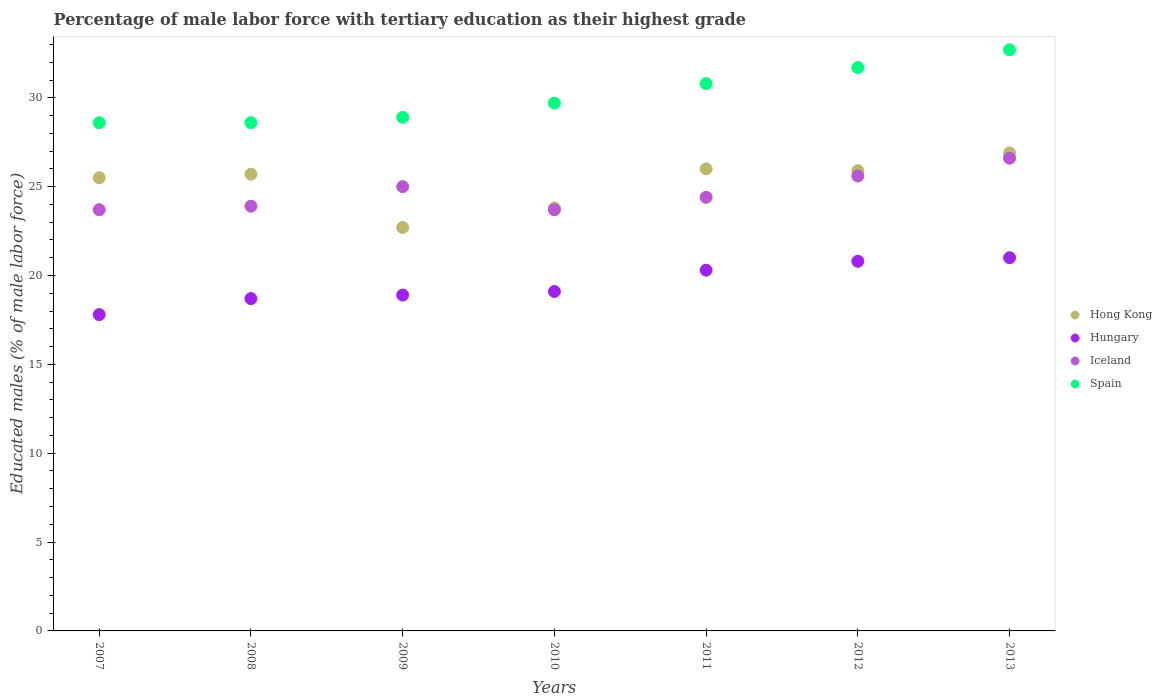Is the number of dotlines equal to the number of legend labels?
Offer a very short reply. Yes. What is the percentage of male labor force with tertiary education in Hong Kong in 2007?
Provide a short and direct response. 25.5. Across all years, what is the maximum percentage of male labor force with tertiary education in Spain?
Keep it short and to the point. 32.7. Across all years, what is the minimum percentage of male labor force with tertiary education in Hong Kong?
Provide a short and direct response. 22.7. In which year was the percentage of male labor force with tertiary education in Hong Kong maximum?
Make the answer very short. 2013. What is the total percentage of male labor force with tertiary education in Hong Kong in the graph?
Your answer should be very brief. 176.5. What is the difference between the percentage of male labor force with tertiary education in Hungary in 2013 and the percentage of male labor force with tertiary education in Spain in 2007?
Ensure brevity in your answer.  -7.6. What is the average percentage of male labor force with tertiary education in Spain per year?
Ensure brevity in your answer.  30.14. In the year 2009, what is the difference between the percentage of male labor force with tertiary education in Hong Kong and percentage of male labor force with tertiary education in Spain?
Keep it short and to the point. -6.2. What is the ratio of the percentage of male labor force with tertiary education in Hong Kong in 2007 to that in 2009?
Keep it short and to the point. 1.12. Is the percentage of male labor force with tertiary education in Hungary in 2007 less than that in 2012?
Keep it short and to the point. Yes. Is the difference between the percentage of male labor force with tertiary education in Hong Kong in 2007 and 2013 greater than the difference between the percentage of male labor force with tertiary education in Spain in 2007 and 2013?
Your response must be concise. Yes. What is the difference between the highest and the second highest percentage of male labor force with tertiary education in Iceland?
Give a very brief answer. 1. What is the difference between the highest and the lowest percentage of male labor force with tertiary education in Spain?
Your answer should be compact. 4.1. Is the sum of the percentage of male labor force with tertiary education in Iceland in 2008 and 2013 greater than the maximum percentage of male labor force with tertiary education in Spain across all years?
Keep it short and to the point. Yes. Is it the case that in every year, the sum of the percentage of male labor force with tertiary education in Iceland and percentage of male labor force with tertiary education in Hungary  is greater than the percentage of male labor force with tertiary education in Spain?
Your answer should be compact. Yes. Does the percentage of male labor force with tertiary education in Iceland monotonically increase over the years?
Offer a terse response. No. Is the percentage of male labor force with tertiary education in Spain strictly greater than the percentage of male labor force with tertiary education in Hong Kong over the years?
Your response must be concise. Yes. Is the percentage of male labor force with tertiary education in Hungary strictly less than the percentage of male labor force with tertiary education in Iceland over the years?
Provide a succinct answer. Yes. How many dotlines are there?
Your answer should be compact. 4. What is the difference between two consecutive major ticks on the Y-axis?
Make the answer very short. 5. Does the graph contain any zero values?
Make the answer very short. No. What is the title of the graph?
Provide a short and direct response. Percentage of male labor force with tertiary education as their highest grade. What is the label or title of the X-axis?
Provide a succinct answer. Years. What is the label or title of the Y-axis?
Provide a succinct answer. Educated males (% of male labor force). What is the Educated males (% of male labor force) of Hungary in 2007?
Your answer should be compact. 17.8. What is the Educated males (% of male labor force) in Iceland in 2007?
Provide a succinct answer. 23.7. What is the Educated males (% of male labor force) of Spain in 2007?
Offer a very short reply. 28.6. What is the Educated males (% of male labor force) of Hong Kong in 2008?
Your answer should be compact. 25.7. What is the Educated males (% of male labor force) in Hungary in 2008?
Provide a succinct answer. 18.7. What is the Educated males (% of male labor force) in Iceland in 2008?
Offer a terse response. 23.9. What is the Educated males (% of male labor force) of Spain in 2008?
Your response must be concise. 28.6. What is the Educated males (% of male labor force) of Hong Kong in 2009?
Keep it short and to the point. 22.7. What is the Educated males (% of male labor force) in Hungary in 2009?
Offer a terse response. 18.9. What is the Educated males (% of male labor force) in Spain in 2009?
Give a very brief answer. 28.9. What is the Educated males (% of male labor force) in Hong Kong in 2010?
Make the answer very short. 23.8. What is the Educated males (% of male labor force) in Hungary in 2010?
Your answer should be compact. 19.1. What is the Educated males (% of male labor force) in Iceland in 2010?
Keep it short and to the point. 23.7. What is the Educated males (% of male labor force) in Spain in 2010?
Give a very brief answer. 29.7. What is the Educated males (% of male labor force) in Hong Kong in 2011?
Your response must be concise. 26. What is the Educated males (% of male labor force) of Hungary in 2011?
Ensure brevity in your answer.  20.3. What is the Educated males (% of male labor force) of Iceland in 2011?
Offer a very short reply. 24.4. What is the Educated males (% of male labor force) in Spain in 2011?
Offer a terse response. 30.8. What is the Educated males (% of male labor force) of Hong Kong in 2012?
Your response must be concise. 25.9. What is the Educated males (% of male labor force) in Hungary in 2012?
Your response must be concise. 20.8. What is the Educated males (% of male labor force) of Iceland in 2012?
Offer a terse response. 25.6. What is the Educated males (% of male labor force) of Spain in 2012?
Make the answer very short. 31.7. What is the Educated males (% of male labor force) of Hong Kong in 2013?
Your response must be concise. 26.9. What is the Educated males (% of male labor force) of Hungary in 2013?
Ensure brevity in your answer.  21. What is the Educated males (% of male labor force) in Iceland in 2013?
Give a very brief answer. 26.6. What is the Educated males (% of male labor force) of Spain in 2013?
Offer a terse response. 32.7. Across all years, what is the maximum Educated males (% of male labor force) of Hong Kong?
Give a very brief answer. 26.9. Across all years, what is the maximum Educated males (% of male labor force) of Hungary?
Your response must be concise. 21. Across all years, what is the maximum Educated males (% of male labor force) in Iceland?
Your answer should be compact. 26.6. Across all years, what is the maximum Educated males (% of male labor force) in Spain?
Give a very brief answer. 32.7. Across all years, what is the minimum Educated males (% of male labor force) in Hong Kong?
Keep it short and to the point. 22.7. Across all years, what is the minimum Educated males (% of male labor force) in Hungary?
Keep it short and to the point. 17.8. Across all years, what is the minimum Educated males (% of male labor force) of Iceland?
Provide a succinct answer. 23.7. Across all years, what is the minimum Educated males (% of male labor force) in Spain?
Give a very brief answer. 28.6. What is the total Educated males (% of male labor force) in Hong Kong in the graph?
Your response must be concise. 176.5. What is the total Educated males (% of male labor force) of Hungary in the graph?
Your answer should be compact. 136.6. What is the total Educated males (% of male labor force) in Iceland in the graph?
Your answer should be compact. 172.9. What is the total Educated males (% of male labor force) in Spain in the graph?
Make the answer very short. 211. What is the difference between the Educated males (% of male labor force) of Hong Kong in 2007 and that in 2008?
Make the answer very short. -0.2. What is the difference between the Educated males (% of male labor force) of Iceland in 2007 and that in 2008?
Give a very brief answer. -0.2. What is the difference between the Educated males (% of male labor force) of Hong Kong in 2007 and that in 2009?
Give a very brief answer. 2.8. What is the difference between the Educated males (% of male labor force) in Hungary in 2007 and that in 2009?
Offer a very short reply. -1.1. What is the difference between the Educated males (% of male labor force) of Iceland in 2007 and that in 2009?
Your answer should be very brief. -1.3. What is the difference between the Educated males (% of male labor force) of Spain in 2007 and that in 2009?
Your response must be concise. -0.3. What is the difference between the Educated males (% of male labor force) of Spain in 2007 and that in 2010?
Your answer should be compact. -1.1. What is the difference between the Educated males (% of male labor force) of Hong Kong in 2007 and that in 2011?
Give a very brief answer. -0.5. What is the difference between the Educated males (% of male labor force) of Hungary in 2007 and that in 2011?
Your response must be concise. -2.5. What is the difference between the Educated males (% of male labor force) of Iceland in 2007 and that in 2011?
Keep it short and to the point. -0.7. What is the difference between the Educated males (% of male labor force) of Hong Kong in 2007 and that in 2012?
Offer a very short reply. -0.4. What is the difference between the Educated males (% of male labor force) in Hungary in 2007 and that in 2012?
Offer a terse response. -3. What is the difference between the Educated males (% of male labor force) of Iceland in 2007 and that in 2012?
Make the answer very short. -1.9. What is the difference between the Educated males (% of male labor force) of Iceland in 2007 and that in 2013?
Ensure brevity in your answer.  -2.9. What is the difference between the Educated males (% of male labor force) of Hungary in 2008 and that in 2009?
Give a very brief answer. -0.2. What is the difference between the Educated males (% of male labor force) in Hong Kong in 2008 and that in 2010?
Your answer should be very brief. 1.9. What is the difference between the Educated males (% of male labor force) of Hungary in 2008 and that in 2010?
Your response must be concise. -0.4. What is the difference between the Educated males (% of male labor force) of Hungary in 2008 and that in 2011?
Make the answer very short. -1.6. What is the difference between the Educated males (% of male labor force) in Spain in 2008 and that in 2011?
Offer a terse response. -2.2. What is the difference between the Educated males (% of male labor force) of Iceland in 2008 and that in 2012?
Your answer should be very brief. -1.7. What is the difference between the Educated males (% of male labor force) in Hong Kong in 2008 and that in 2013?
Keep it short and to the point. -1.2. What is the difference between the Educated males (% of male labor force) in Hungary in 2008 and that in 2013?
Your response must be concise. -2.3. What is the difference between the Educated males (% of male labor force) of Spain in 2008 and that in 2013?
Offer a terse response. -4.1. What is the difference between the Educated males (% of male labor force) in Hong Kong in 2009 and that in 2010?
Provide a short and direct response. -1.1. What is the difference between the Educated males (% of male labor force) in Spain in 2009 and that in 2010?
Give a very brief answer. -0.8. What is the difference between the Educated males (% of male labor force) of Hong Kong in 2009 and that in 2011?
Give a very brief answer. -3.3. What is the difference between the Educated males (% of male labor force) in Iceland in 2009 and that in 2011?
Provide a succinct answer. 0.6. What is the difference between the Educated males (% of male labor force) in Hong Kong in 2009 and that in 2012?
Give a very brief answer. -3.2. What is the difference between the Educated males (% of male labor force) of Iceland in 2009 and that in 2012?
Offer a very short reply. -0.6. What is the difference between the Educated males (% of male labor force) in Spain in 2009 and that in 2012?
Ensure brevity in your answer.  -2.8. What is the difference between the Educated males (% of male labor force) of Iceland in 2009 and that in 2013?
Offer a very short reply. -1.6. What is the difference between the Educated males (% of male labor force) in Spain in 2009 and that in 2013?
Make the answer very short. -3.8. What is the difference between the Educated males (% of male labor force) in Hong Kong in 2010 and that in 2011?
Provide a succinct answer. -2.2. What is the difference between the Educated males (% of male labor force) of Hungary in 2010 and that in 2011?
Give a very brief answer. -1.2. What is the difference between the Educated males (% of male labor force) in Iceland in 2010 and that in 2011?
Your answer should be very brief. -0.7. What is the difference between the Educated males (% of male labor force) in Hong Kong in 2010 and that in 2012?
Provide a succinct answer. -2.1. What is the difference between the Educated males (% of male labor force) in Iceland in 2010 and that in 2012?
Your answer should be very brief. -1.9. What is the difference between the Educated males (% of male labor force) in Hong Kong in 2010 and that in 2013?
Provide a succinct answer. -3.1. What is the difference between the Educated males (% of male labor force) of Iceland in 2010 and that in 2013?
Give a very brief answer. -2.9. What is the difference between the Educated males (% of male labor force) of Spain in 2010 and that in 2013?
Your response must be concise. -3. What is the difference between the Educated males (% of male labor force) in Hungary in 2011 and that in 2012?
Provide a succinct answer. -0.5. What is the difference between the Educated males (% of male labor force) in Hong Kong in 2011 and that in 2013?
Offer a very short reply. -0.9. What is the difference between the Educated males (% of male labor force) in Hungary in 2012 and that in 2013?
Your answer should be compact. -0.2. What is the difference between the Educated males (% of male labor force) in Spain in 2012 and that in 2013?
Offer a terse response. -1. What is the difference between the Educated males (% of male labor force) of Hong Kong in 2007 and the Educated males (% of male labor force) of Hungary in 2008?
Your response must be concise. 6.8. What is the difference between the Educated males (% of male labor force) in Hungary in 2007 and the Educated males (% of male labor force) in Spain in 2008?
Ensure brevity in your answer.  -10.8. What is the difference between the Educated males (% of male labor force) of Hong Kong in 2007 and the Educated males (% of male labor force) of Hungary in 2009?
Your answer should be very brief. 6.6. What is the difference between the Educated males (% of male labor force) of Hungary in 2007 and the Educated males (% of male labor force) of Spain in 2009?
Ensure brevity in your answer.  -11.1. What is the difference between the Educated males (% of male labor force) of Hungary in 2007 and the Educated males (% of male labor force) of Iceland in 2010?
Your answer should be compact. -5.9. What is the difference between the Educated males (% of male labor force) in Hungary in 2007 and the Educated males (% of male labor force) in Spain in 2010?
Provide a succinct answer. -11.9. What is the difference between the Educated males (% of male labor force) of Iceland in 2007 and the Educated males (% of male labor force) of Spain in 2010?
Your answer should be compact. -6. What is the difference between the Educated males (% of male labor force) of Hong Kong in 2007 and the Educated males (% of male labor force) of Iceland in 2011?
Keep it short and to the point. 1.1. What is the difference between the Educated males (% of male labor force) of Hungary in 2007 and the Educated males (% of male labor force) of Iceland in 2011?
Give a very brief answer. -6.6. What is the difference between the Educated males (% of male labor force) of Iceland in 2007 and the Educated males (% of male labor force) of Spain in 2011?
Offer a terse response. -7.1. What is the difference between the Educated males (% of male labor force) of Hong Kong in 2007 and the Educated males (% of male labor force) of Iceland in 2012?
Make the answer very short. -0.1. What is the difference between the Educated males (% of male labor force) in Hong Kong in 2007 and the Educated males (% of male labor force) in Spain in 2012?
Your answer should be very brief. -6.2. What is the difference between the Educated males (% of male labor force) in Hungary in 2007 and the Educated males (% of male labor force) in Iceland in 2012?
Make the answer very short. -7.8. What is the difference between the Educated males (% of male labor force) in Hungary in 2007 and the Educated males (% of male labor force) in Spain in 2012?
Your response must be concise. -13.9. What is the difference between the Educated males (% of male labor force) of Hong Kong in 2007 and the Educated males (% of male labor force) of Iceland in 2013?
Provide a succinct answer. -1.1. What is the difference between the Educated males (% of male labor force) in Hong Kong in 2007 and the Educated males (% of male labor force) in Spain in 2013?
Keep it short and to the point. -7.2. What is the difference between the Educated males (% of male labor force) of Hungary in 2007 and the Educated males (% of male labor force) of Spain in 2013?
Provide a short and direct response. -14.9. What is the difference between the Educated males (% of male labor force) of Iceland in 2007 and the Educated males (% of male labor force) of Spain in 2013?
Your answer should be compact. -9. What is the difference between the Educated males (% of male labor force) of Hong Kong in 2008 and the Educated males (% of male labor force) of Hungary in 2009?
Make the answer very short. 6.8. What is the difference between the Educated males (% of male labor force) in Hungary in 2008 and the Educated males (% of male labor force) in Iceland in 2009?
Provide a short and direct response. -6.3. What is the difference between the Educated males (% of male labor force) in Iceland in 2008 and the Educated males (% of male labor force) in Spain in 2009?
Provide a succinct answer. -5. What is the difference between the Educated males (% of male labor force) in Hong Kong in 2008 and the Educated males (% of male labor force) in Iceland in 2010?
Give a very brief answer. 2. What is the difference between the Educated males (% of male labor force) in Hong Kong in 2008 and the Educated males (% of male labor force) in Spain in 2010?
Provide a short and direct response. -4. What is the difference between the Educated males (% of male labor force) in Hungary in 2008 and the Educated males (% of male labor force) in Spain in 2010?
Your response must be concise. -11. What is the difference between the Educated males (% of male labor force) of Hong Kong in 2008 and the Educated males (% of male labor force) of Hungary in 2012?
Your answer should be compact. 4.9. What is the difference between the Educated males (% of male labor force) in Hong Kong in 2008 and the Educated males (% of male labor force) in Hungary in 2013?
Provide a succinct answer. 4.7. What is the difference between the Educated males (% of male labor force) in Hungary in 2008 and the Educated males (% of male labor force) in Iceland in 2013?
Make the answer very short. -7.9. What is the difference between the Educated males (% of male labor force) of Hungary in 2008 and the Educated males (% of male labor force) of Spain in 2013?
Offer a terse response. -14. What is the difference between the Educated males (% of male labor force) of Hong Kong in 2009 and the Educated males (% of male labor force) of Hungary in 2010?
Your answer should be very brief. 3.6. What is the difference between the Educated males (% of male labor force) of Hong Kong in 2009 and the Educated males (% of male labor force) of Spain in 2010?
Make the answer very short. -7. What is the difference between the Educated males (% of male labor force) in Hungary in 2009 and the Educated males (% of male labor force) in Iceland in 2010?
Your answer should be compact. -4.8. What is the difference between the Educated males (% of male labor force) in Hungary in 2009 and the Educated males (% of male labor force) in Spain in 2010?
Ensure brevity in your answer.  -10.8. What is the difference between the Educated males (% of male labor force) of Iceland in 2009 and the Educated males (% of male labor force) of Spain in 2010?
Offer a terse response. -4.7. What is the difference between the Educated males (% of male labor force) of Hong Kong in 2009 and the Educated males (% of male labor force) of Spain in 2011?
Provide a succinct answer. -8.1. What is the difference between the Educated males (% of male labor force) in Hungary in 2009 and the Educated males (% of male labor force) in Iceland in 2011?
Offer a terse response. -5.5. What is the difference between the Educated males (% of male labor force) in Hungary in 2009 and the Educated males (% of male labor force) in Spain in 2011?
Ensure brevity in your answer.  -11.9. What is the difference between the Educated males (% of male labor force) in Hong Kong in 2009 and the Educated males (% of male labor force) in Spain in 2012?
Your response must be concise. -9. What is the difference between the Educated males (% of male labor force) in Hungary in 2009 and the Educated males (% of male labor force) in Spain in 2012?
Your response must be concise. -12.8. What is the difference between the Educated males (% of male labor force) in Iceland in 2009 and the Educated males (% of male labor force) in Spain in 2012?
Provide a short and direct response. -6.7. What is the difference between the Educated males (% of male labor force) of Hong Kong in 2009 and the Educated males (% of male labor force) of Iceland in 2013?
Keep it short and to the point. -3.9. What is the difference between the Educated males (% of male labor force) in Hong Kong in 2009 and the Educated males (% of male labor force) in Spain in 2013?
Ensure brevity in your answer.  -10. What is the difference between the Educated males (% of male labor force) in Iceland in 2009 and the Educated males (% of male labor force) in Spain in 2013?
Offer a terse response. -7.7. What is the difference between the Educated males (% of male labor force) in Hungary in 2010 and the Educated males (% of male labor force) in Iceland in 2011?
Your answer should be very brief. -5.3. What is the difference between the Educated males (% of male labor force) in Hungary in 2010 and the Educated males (% of male labor force) in Spain in 2011?
Your response must be concise. -11.7. What is the difference between the Educated males (% of male labor force) in Iceland in 2010 and the Educated males (% of male labor force) in Spain in 2011?
Keep it short and to the point. -7.1. What is the difference between the Educated males (% of male labor force) of Hong Kong in 2010 and the Educated males (% of male labor force) of Spain in 2012?
Give a very brief answer. -7.9. What is the difference between the Educated males (% of male labor force) in Hungary in 2010 and the Educated males (% of male labor force) in Spain in 2012?
Give a very brief answer. -12.6. What is the difference between the Educated males (% of male labor force) in Iceland in 2010 and the Educated males (% of male labor force) in Spain in 2012?
Give a very brief answer. -8. What is the difference between the Educated males (% of male labor force) of Hong Kong in 2010 and the Educated males (% of male labor force) of Hungary in 2013?
Provide a short and direct response. 2.8. What is the difference between the Educated males (% of male labor force) of Iceland in 2010 and the Educated males (% of male labor force) of Spain in 2013?
Keep it short and to the point. -9. What is the difference between the Educated males (% of male labor force) in Hong Kong in 2011 and the Educated males (% of male labor force) in Hungary in 2012?
Provide a short and direct response. 5.2. What is the difference between the Educated males (% of male labor force) of Hong Kong in 2011 and the Educated males (% of male labor force) of Spain in 2012?
Ensure brevity in your answer.  -5.7. What is the difference between the Educated males (% of male labor force) of Hong Kong in 2011 and the Educated males (% of male labor force) of Hungary in 2013?
Make the answer very short. 5. What is the difference between the Educated males (% of male labor force) in Hong Kong in 2011 and the Educated males (% of male labor force) in Iceland in 2013?
Keep it short and to the point. -0.6. What is the difference between the Educated males (% of male labor force) of Hong Kong in 2012 and the Educated males (% of male labor force) of Hungary in 2013?
Give a very brief answer. 4.9. What is the difference between the Educated males (% of male labor force) in Hong Kong in 2012 and the Educated males (% of male labor force) in Iceland in 2013?
Give a very brief answer. -0.7. What is the difference between the Educated males (% of male labor force) in Hungary in 2012 and the Educated males (% of male labor force) in Spain in 2013?
Offer a very short reply. -11.9. What is the difference between the Educated males (% of male labor force) in Iceland in 2012 and the Educated males (% of male labor force) in Spain in 2013?
Keep it short and to the point. -7.1. What is the average Educated males (% of male labor force) of Hong Kong per year?
Provide a succinct answer. 25.21. What is the average Educated males (% of male labor force) of Hungary per year?
Your answer should be compact. 19.51. What is the average Educated males (% of male labor force) in Iceland per year?
Your answer should be very brief. 24.7. What is the average Educated males (% of male labor force) of Spain per year?
Your response must be concise. 30.14. In the year 2007, what is the difference between the Educated males (% of male labor force) in Hong Kong and Educated males (% of male labor force) in Spain?
Give a very brief answer. -3.1. In the year 2007, what is the difference between the Educated males (% of male labor force) in Iceland and Educated males (% of male labor force) in Spain?
Your answer should be compact. -4.9. In the year 2008, what is the difference between the Educated males (% of male labor force) of Hong Kong and Educated males (% of male labor force) of Hungary?
Keep it short and to the point. 7. In the year 2008, what is the difference between the Educated males (% of male labor force) of Hungary and Educated males (% of male labor force) of Spain?
Keep it short and to the point. -9.9. In the year 2009, what is the difference between the Educated males (% of male labor force) in Hong Kong and Educated males (% of male labor force) in Spain?
Provide a succinct answer. -6.2. In the year 2009, what is the difference between the Educated males (% of male labor force) in Hungary and Educated males (% of male labor force) in Iceland?
Offer a terse response. -6.1. In the year 2009, what is the difference between the Educated males (% of male labor force) of Hungary and Educated males (% of male labor force) of Spain?
Offer a very short reply. -10. In the year 2009, what is the difference between the Educated males (% of male labor force) of Iceland and Educated males (% of male labor force) of Spain?
Your answer should be compact. -3.9. In the year 2010, what is the difference between the Educated males (% of male labor force) of Hong Kong and Educated males (% of male labor force) of Iceland?
Provide a short and direct response. 0.1. In the year 2010, what is the difference between the Educated males (% of male labor force) in Hungary and Educated males (% of male labor force) in Spain?
Your response must be concise. -10.6. In the year 2010, what is the difference between the Educated males (% of male labor force) in Iceland and Educated males (% of male labor force) in Spain?
Your answer should be compact. -6. In the year 2011, what is the difference between the Educated males (% of male labor force) of Hong Kong and Educated males (% of male labor force) of Hungary?
Give a very brief answer. 5.7. In the year 2011, what is the difference between the Educated males (% of male labor force) of Hungary and Educated males (% of male labor force) of Spain?
Ensure brevity in your answer.  -10.5. In the year 2012, what is the difference between the Educated males (% of male labor force) in Hong Kong and Educated males (% of male labor force) in Iceland?
Ensure brevity in your answer.  0.3. In the year 2012, what is the difference between the Educated males (% of male labor force) of Hong Kong and Educated males (% of male labor force) of Spain?
Your answer should be very brief. -5.8. In the year 2012, what is the difference between the Educated males (% of male labor force) of Hungary and Educated males (% of male labor force) of Iceland?
Offer a very short reply. -4.8. In the year 2012, what is the difference between the Educated males (% of male labor force) in Hungary and Educated males (% of male labor force) in Spain?
Make the answer very short. -10.9. In the year 2012, what is the difference between the Educated males (% of male labor force) of Iceland and Educated males (% of male labor force) of Spain?
Your answer should be very brief. -6.1. In the year 2013, what is the difference between the Educated males (% of male labor force) in Hong Kong and Educated males (% of male labor force) in Hungary?
Make the answer very short. 5.9. In the year 2013, what is the difference between the Educated males (% of male labor force) of Hungary and Educated males (% of male labor force) of Spain?
Make the answer very short. -11.7. What is the ratio of the Educated males (% of male labor force) in Hungary in 2007 to that in 2008?
Offer a terse response. 0.95. What is the ratio of the Educated males (% of male labor force) in Spain in 2007 to that in 2008?
Your answer should be very brief. 1. What is the ratio of the Educated males (% of male labor force) in Hong Kong in 2007 to that in 2009?
Ensure brevity in your answer.  1.12. What is the ratio of the Educated males (% of male labor force) in Hungary in 2007 to that in 2009?
Ensure brevity in your answer.  0.94. What is the ratio of the Educated males (% of male labor force) of Iceland in 2007 to that in 2009?
Your answer should be compact. 0.95. What is the ratio of the Educated males (% of male labor force) of Spain in 2007 to that in 2009?
Ensure brevity in your answer.  0.99. What is the ratio of the Educated males (% of male labor force) of Hong Kong in 2007 to that in 2010?
Make the answer very short. 1.07. What is the ratio of the Educated males (% of male labor force) in Hungary in 2007 to that in 2010?
Offer a terse response. 0.93. What is the ratio of the Educated males (% of male labor force) in Hong Kong in 2007 to that in 2011?
Offer a very short reply. 0.98. What is the ratio of the Educated males (% of male labor force) in Hungary in 2007 to that in 2011?
Offer a terse response. 0.88. What is the ratio of the Educated males (% of male labor force) in Iceland in 2007 to that in 2011?
Your response must be concise. 0.97. What is the ratio of the Educated males (% of male labor force) of Spain in 2007 to that in 2011?
Ensure brevity in your answer.  0.93. What is the ratio of the Educated males (% of male labor force) of Hong Kong in 2007 to that in 2012?
Make the answer very short. 0.98. What is the ratio of the Educated males (% of male labor force) of Hungary in 2007 to that in 2012?
Your answer should be compact. 0.86. What is the ratio of the Educated males (% of male labor force) of Iceland in 2007 to that in 2012?
Provide a succinct answer. 0.93. What is the ratio of the Educated males (% of male labor force) in Spain in 2007 to that in 2012?
Provide a short and direct response. 0.9. What is the ratio of the Educated males (% of male labor force) of Hong Kong in 2007 to that in 2013?
Your answer should be very brief. 0.95. What is the ratio of the Educated males (% of male labor force) in Hungary in 2007 to that in 2013?
Provide a short and direct response. 0.85. What is the ratio of the Educated males (% of male labor force) of Iceland in 2007 to that in 2013?
Make the answer very short. 0.89. What is the ratio of the Educated males (% of male labor force) of Spain in 2007 to that in 2013?
Offer a terse response. 0.87. What is the ratio of the Educated males (% of male labor force) in Hong Kong in 2008 to that in 2009?
Your answer should be compact. 1.13. What is the ratio of the Educated males (% of male labor force) in Iceland in 2008 to that in 2009?
Your answer should be compact. 0.96. What is the ratio of the Educated males (% of male labor force) in Spain in 2008 to that in 2009?
Give a very brief answer. 0.99. What is the ratio of the Educated males (% of male labor force) in Hong Kong in 2008 to that in 2010?
Your answer should be compact. 1.08. What is the ratio of the Educated males (% of male labor force) in Hungary in 2008 to that in 2010?
Keep it short and to the point. 0.98. What is the ratio of the Educated males (% of male labor force) in Iceland in 2008 to that in 2010?
Ensure brevity in your answer.  1.01. What is the ratio of the Educated males (% of male labor force) in Hungary in 2008 to that in 2011?
Offer a terse response. 0.92. What is the ratio of the Educated males (% of male labor force) of Iceland in 2008 to that in 2011?
Provide a succinct answer. 0.98. What is the ratio of the Educated males (% of male labor force) in Hungary in 2008 to that in 2012?
Your answer should be very brief. 0.9. What is the ratio of the Educated males (% of male labor force) of Iceland in 2008 to that in 2012?
Keep it short and to the point. 0.93. What is the ratio of the Educated males (% of male labor force) of Spain in 2008 to that in 2012?
Your answer should be very brief. 0.9. What is the ratio of the Educated males (% of male labor force) of Hong Kong in 2008 to that in 2013?
Offer a very short reply. 0.96. What is the ratio of the Educated males (% of male labor force) in Hungary in 2008 to that in 2013?
Provide a short and direct response. 0.89. What is the ratio of the Educated males (% of male labor force) of Iceland in 2008 to that in 2013?
Keep it short and to the point. 0.9. What is the ratio of the Educated males (% of male labor force) of Spain in 2008 to that in 2013?
Offer a terse response. 0.87. What is the ratio of the Educated males (% of male labor force) of Hong Kong in 2009 to that in 2010?
Provide a short and direct response. 0.95. What is the ratio of the Educated males (% of male labor force) in Iceland in 2009 to that in 2010?
Offer a terse response. 1.05. What is the ratio of the Educated males (% of male labor force) of Spain in 2009 to that in 2010?
Keep it short and to the point. 0.97. What is the ratio of the Educated males (% of male labor force) in Hong Kong in 2009 to that in 2011?
Make the answer very short. 0.87. What is the ratio of the Educated males (% of male labor force) in Iceland in 2009 to that in 2011?
Your answer should be very brief. 1.02. What is the ratio of the Educated males (% of male labor force) of Spain in 2009 to that in 2011?
Offer a very short reply. 0.94. What is the ratio of the Educated males (% of male labor force) of Hong Kong in 2009 to that in 2012?
Make the answer very short. 0.88. What is the ratio of the Educated males (% of male labor force) of Hungary in 2009 to that in 2012?
Your answer should be compact. 0.91. What is the ratio of the Educated males (% of male labor force) in Iceland in 2009 to that in 2012?
Your answer should be very brief. 0.98. What is the ratio of the Educated males (% of male labor force) in Spain in 2009 to that in 2012?
Your answer should be very brief. 0.91. What is the ratio of the Educated males (% of male labor force) of Hong Kong in 2009 to that in 2013?
Your answer should be very brief. 0.84. What is the ratio of the Educated males (% of male labor force) in Iceland in 2009 to that in 2013?
Provide a short and direct response. 0.94. What is the ratio of the Educated males (% of male labor force) of Spain in 2009 to that in 2013?
Provide a succinct answer. 0.88. What is the ratio of the Educated males (% of male labor force) in Hong Kong in 2010 to that in 2011?
Offer a terse response. 0.92. What is the ratio of the Educated males (% of male labor force) in Hungary in 2010 to that in 2011?
Your answer should be very brief. 0.94. What is the ratio of the Educated males (% of male labor force) in Iceland in 2010 to that in 2011?
Make the answer very short. 0.97. What is the ratio of the Educated males (% of male labor force) of Hong Kong in 2010 to that in 2012?
Provide a short and direct response. 0.92. What is the ratio of the Educated males (% of male labor force) in Hungary in 2010 to that in 2012?
Give a very brief answer. 0.92. What is the ratio of the Educated males (% of male labor force) in Iceland in 2010 to that in 2012?
Your answer should be compact. 0.93. What is the ratio of the Educated males (% of male labor force) in Spain in 2010 to that in 2012?
Your response must be concise. 0.94. What is the ratio of the Educated males (% of male labor force) in Hong Kong in 2010 to that in 2013?
Offer a terse response. 0.88. What is the ratio of the Educated males (% of male labor force) of Hungary in 2010 to that in 2013?
Make the answer very short. 0.91. What is the ratio of the Educated males (% of male labor force) in Iceland in 2010 to that in 2013?
Provide a succinct answer. 0.89. What is the ratio of the Educated males (% of male labor force) of Spain in 2010 to that in 2013?
Provide a short and direct response. 0.91. What is the ratio of the Educated males (% of male labor force) of Hungary in 2011 to that in 2012?
Ensure brevity in your answer.  0.98. What is the ratio of the Educated males (% of male labor force) in Iceland in 2011 to that in 2012?
Offer a terse response. 0.95. What is the ratio of the Educated males (% of male labor force) of Spain in 2011 to that in 2012?
Make the answer very short. 0.97. What is the ratio of the Educated males (% of male labor force) in Hong Kong in 2011 to that in 2013?
Offer a very short reply. 0.97. What is the ratio of the Educated males (% of male labor force) of Hungary in 2011 to that in 2013?
Your response must be concise. 0.97. What is the ratio of the Educated males (% of male labor force) of Iceland in 2011 to that in 2013?
Provide a succinct answer. 0.92. What is the ratio of the Educated males (% of male labor force) of Spain in 2011 to that in 2013?
Keep it short and to the point. 0.94. What is the ratio of the Educated males (% of male labor force) of Hong Kong in 2012 to that in 2013?
Keep it short and to the point. 0.96. What is the ratio of the Educated males (% of male labor force) in Hungary in 2012 to that in 2013?
Provide a succinct answer. 0.99. What is the ratio of the Educated males (% of male labor force) in Iceland in 2012 to that in 2013?
Ensure brevity in your answer.  0.96. What is the ratio of the Educated males (% of male labor force) of Spain in 2012 to that in 2013?
Keep it short and to the point. 0.97. What is the difference between the highest and the second highest Educated males (% of male labor force) in Hong Kong?
Ensure brevity in your answer.  0.9. What is the difference between the highest and the second highest Educated males (% of male labor force) of Hungary?
Give a very brief answer. 0.2. What is the difference between the highest and the second highest Educated males (% of male labor force) of Spain?
Your response must be concise. 1. What is the difference between the highest and the lowest Educated males (% of male labor force) of Hong Kong?
Your answer should be compact. 4.2. What is the difference between the highest and the lowest Educated males (% of male labor force) in Hungary?
Your response must be concise. 3.2. What is the difference between the highest and the lowest Educated males (% of male labor force) in Spain?
Offer a very short reply. 4.1. 